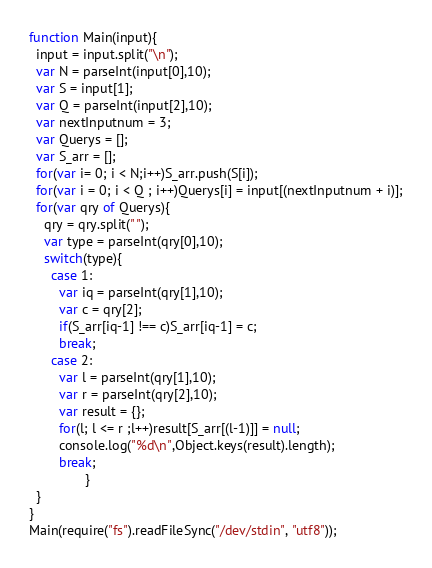Convert code to text. <code><loc_0><loc_0><loc_500><loc_500><_JavaScript_>function Main(input){
  input = input.split("\n");
  var N = parseInt(input[0],10);
  var S = input[1];
  var Q = parseInt(input[2],10);
  var nextInputnum = 3;
  var Querys = [];
  var S_arr = [];
  for(var i= 0; i < N;i++)S_arr.push(S[i]);
  for(var i = 0; i < Q ; i++)Querys[i] = input[(nextInputnum + i)];
  for(var qry of Querys){
    qry = qry.split(" ");
    var type = parseInt(qry[0],10);
    switch(type){
      case 1:
        var iq = parseInt(qry[1],10);
        var c = qry[2];
        if(S_arr[iq-1] !== c)S_arr[iq-1] = c;
        break;
      case 2:
        var l = parseInt(qry[1],10);
        var r = parseInt(qry[2],10);
        var result = {};
        for(l; l <= r ;l++)result[S_arr[(l-1)]] = null;
        console.log("%d\n",Object.keys(result).length);
        break;
               }
  }
}
Main(require("fs").readFileSync("/dev/stdin", "utf8"));
</code> 